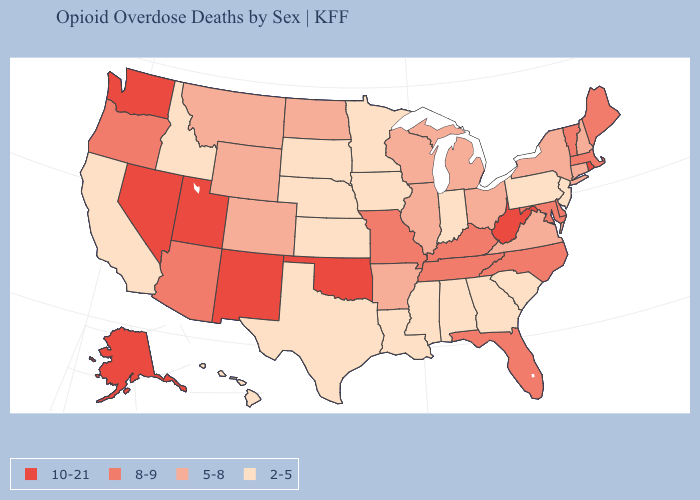Which states hav the highest value in the West?
Answer briefly. Alaska, Nevada, New Mexico, Utah, Washington. What is the lowest value in the USA?
Keep it brief. 2-5. Does Washington have the same value as Utah?
Be succinct. Yes. How many symbols are there in the legend?
Answer briefly. 4. Does the map have missing data?
Concise answer only. No. Does the map have missing data?
Write a very short answer. No. Does Alaska have the highest value in the USA?
Short answer required. Yes. What is the value of Florida?
Short answer required. 8-9. What is the value of North Dakota?
Give a very brief answer. 5-8. Among the states that border Oklahoma , which have the highest value?
Concise answer only. New Mexico. Among the states that border Nebraska , does Colorado have the lowest value?
Quick response, please. No. Which states have the lowest value in the Northeast?
Write a very short answer. New Jersey, Pennsylvania. Which states hav the highest value in the South?
Write a very short answer. Oklahoma, West Virginia. Name the states that have a value in the range 10-21?
Concise answer only. Alaska, Nevada, New Mexico, Oklahoma, Rhode Island, Utah, Washington, West Virginia. Does Indiana have the same value as Georgia?
Quick response, please. Yes. 